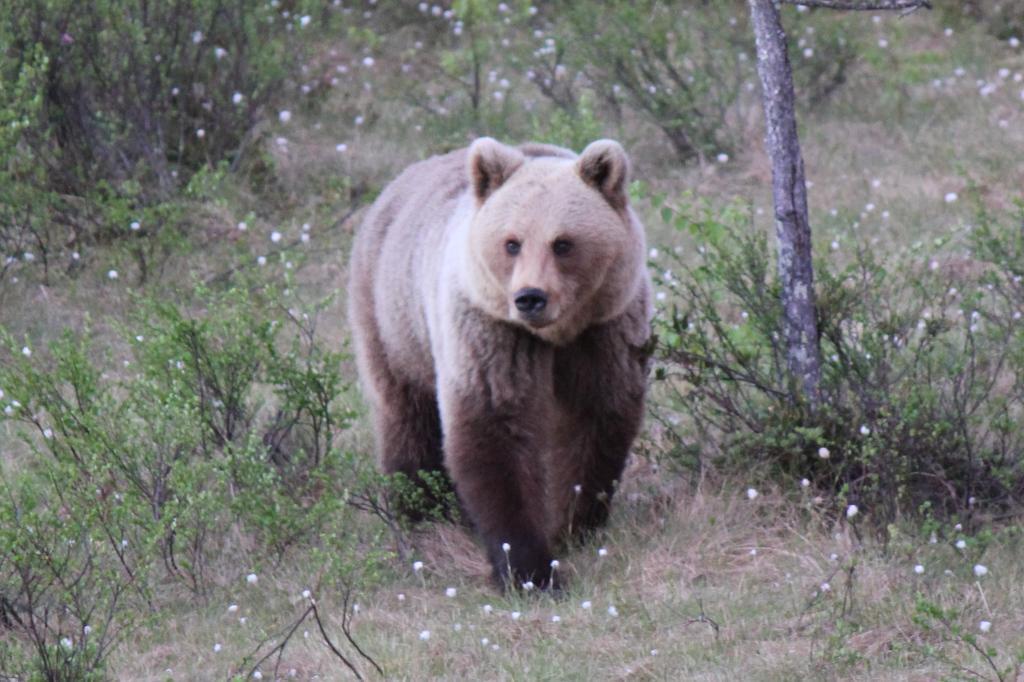How would you summarize this image in a sentence or two? In this image there is a bear, on a grassland in the background there are plants. 